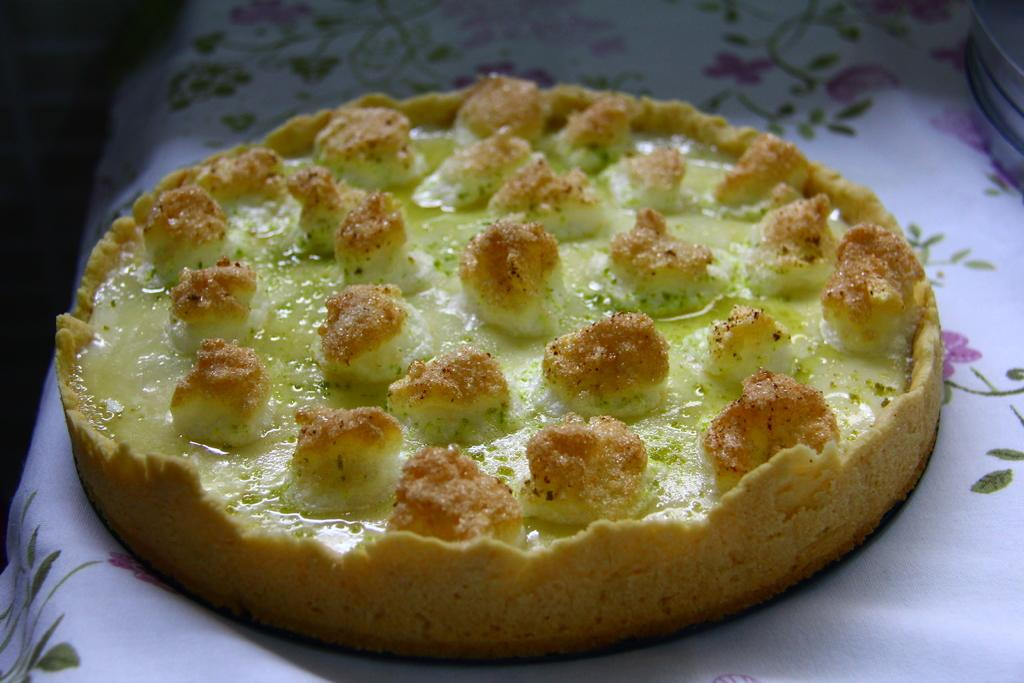What type of food is visible on the table in the image? There is a pizza on the table in the image. What is the level of pollution is present in the image? There is no information about pollution in the image, as it only shows a pizza on a table. What time of day is depicted in the image? The time of day is not specified in the image, as it only shows a pizza on a table. 